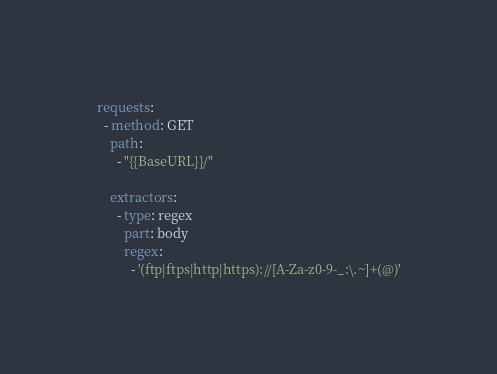Convert code to text. <code><loc_0><loc_0><loc_500><loc_500><_YAML_>
requests:
  - method: GET
    path:
      - "{{BaseURL}}/"

    extractors:
      - type: regex
        part: body
        regex:
          - '(ftp|ftps|http|https)://[A-Za-z0-9-_:\.~]+(@)'
</code> 